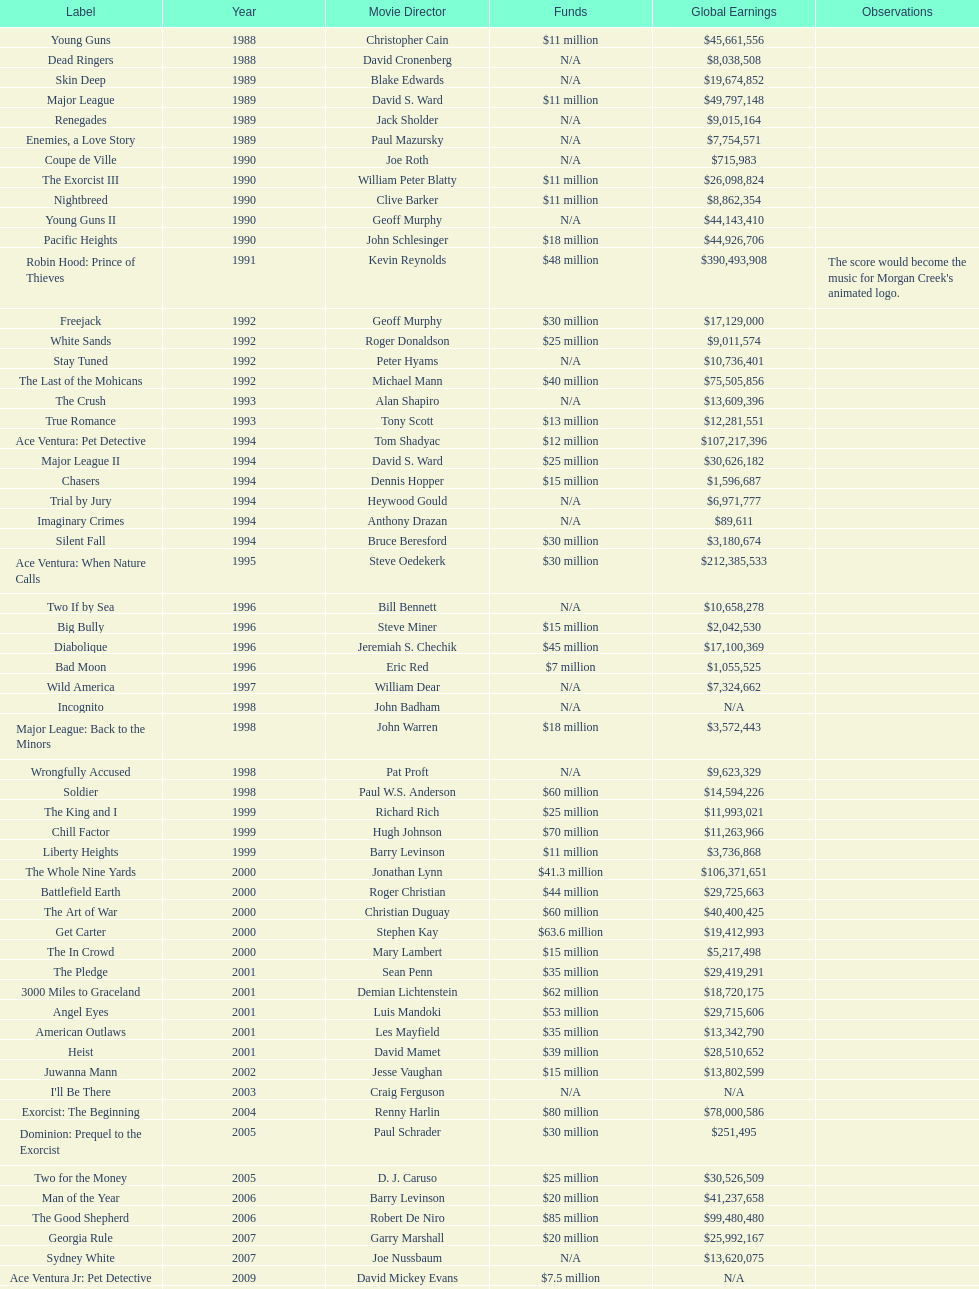Write the full table. {'header': ['Label', 'Year', 'Movie Director', 'Funds', 'Global Earnings', 'Observations'], 'rows': [['Young Guns', '1988', 'Christopher Cain', '$11 million', '$45,661,556', ''], ['Dead Ringers', '1988', 'David Cronenberg', 'N/A', '$8,038,508', ''], ['Skin Deep', '1989', 'Blake Edwards', 'N/A', '$19,674,852', ''], ['Major League', '1989', 'David S. Ward', '$11 million', '$49,797,148', ''], ['Renegades', '1989', 'Jack Sholder', 'N/A', '$9,015,164', ''], ['Enemies, a Love Story', '1989', 'Paul Mazursky', 'N/A', '$7,754,571', ''], ['Coupe de Ville', '1990', 'Joe Roth', 'N/A', '$715,983', ''], ['The Exorcist III', '1990', 'William Peter Blatty', '$11 million', '$26,098,824', ''], ['Nightbreed', '1990', 'Clive Barker', '$11 million', '$8,862,354', ''], ['Young Guns II', '1990', 'Geoff Murphy', 'N/A', '$44,143,410', ''], ['Pacific Heights', '1990', 'John Schlesinger', '$18 million', '$44,926,706', ''], ['Robin Hood: Prince of Thieves', '1991', 'Kevin Reynolds', '$48 million', '$390,493,908', "The score would become the music for Morgan Creek's animated logo."], ['Freejack', '1992', 'Geoff Murphy', '$30 million', '$17,129,000', ''], ['White Sands', '1992', 'Roger Donaldson', '$25 million', '$9,011,574', ''], ['Stay Tuned', '1992', 'Peter Hyams', 'N/A', '$10,736,401', ''], ['The Last of the Mohicans', '1992', 'Michael Mann', '$40 million', '$75,505,856', ''], ['The Crush', '1993', 'Alan Shapiro', 'N/A', '$13,609,396', ''], ['True Romance', '1993', 'Tony Scott', '$13 million', '$12,281,551', ''], ['Ace Ventura: Pet Detective', '1994', 'Tom Shadyac', '$12 million', '$107,217,396', ''], ['Major League II', '1994', 'David S. Ward', '$25 million', '$30,626,182', ''], ['Chasers', '1994', 'Dennis Hopper', '$15 million', '$1,596,687', ''], ['Trial by Jury', '1994', 'Heywood Gould', 'N/A', '$6,971,777', ''], ['Imaginary Crimes', '1994', 'Anthony Drazan', 'N/A', '$89,611', ''], ['Silent Fall', '1994', 'Bruce Beresford', '$30 million', '$3,180,674', ''], ['Ace Ventura: When Nature Calls', '1995', 'Steve Oedekerk', '$30 million', '$212,385,533', ''], ['Two If by Sea', '1996', 'Bill Bennett', 'N/A', '$10,658,278', ''], ['Big Bully', '1996', 'Steve Miner', '$15 million', '$2,042,530', ''], ['Diabolique', '1996', 'Jeremiah S. Chechik', '$45 million', '$17,100,369', ''], ['Bad Moon', '1996', 'Eric Red', '$7 million', '$1,055,525', ''], ['Wild America', '1997', 'William Dear', 'N/A', '$7,324,662', ''], ['Incognito', '1998', 'John Badham', 'N/A', 'N/A', ''], ['Major League: Back to the Minors', '1998', 'John Warren', '$18 million', '$3,572,443', ''], ['Wrongfully Accused', '1998', 'Pat Proft', 'N/A', '$9,623,329', ''], ['Soldier', '1998', 'Paul W.S. Anderson', '$60 million', '$14,594,226', ''], ['The King and I', '1999', 'Richard Rich', '$25 million', '$11,993,021', ''], ['Chill Factor', '1999', 'Hugh Johnson', '$70 million', '$11,263,966', ''], ['Liberty Heights', '1999', 'Barry Levinson', '$11 million', '$3,736,868', ''], ['The Whole Nine Yards', '2000', 'Jonathan Lynn', '$41.3 million', '$106,371,651', ''], ['Battlefield Earth', '2000', 'Roger Christian', '$44 million', '$29,725,663', ''], ['The Art of War', '2000', 'Christian Duguay', '$60 million', '$40,400,425', ''], ['Get Carter', '2000', 'Stephen Kay', '$63.6 million', '$19,412,993', ''], ['The In Crowd', '2000', 'Mary Lambert', '$15 million', '$5,217,498', ''], ['The Pledge', '2001', 'Sean Penn', '$35 million', '$29,419,291', ''], ['3000 Miles to Graceland', '2001', 'Demian Lichtenstein', '$62 million', '$18,720,175', ''], ['Angel Eyes', '2001', 'Luis Mandoki', '$53 million', '$29,715,606', ''], ['American Outlaws', '2001', 'Les Mayfield', '$35 million', '$13,342,790', ''], ['Heist', '2001', 'David Mamet', '$39 million', '$28,510,652', ''], ['Juwanna Mann', '2002', 'Jesse Vaughan', '$15 million', '$13,802,599', ''], ["I'll Be There", '2003', 'Craig Ferguson', 'N/A', 'N/A', ''], ['Exorcist: The Beginning', '2004', 'Renny Harlin', '$80 million', '$78,000,586', ''], ['Dominion: Prequel to the Exorcist', '2005', 'Paul Schrader', '$30 million', '$251,495', ''], ['Two for the Money', '2005', 'D. J. Caruso', '$25 million', '$30,526,509', ''], ['Man of the Year', '2006', 'Barry Levinson', '$20 million', '$41,237,658', ''], ['The Good Shepherd', '2006', 'Robert De Niro', '$85 million', '$99,480,480', ''], ['Georgia Rule', '2007', 'Garry Marshall', '$20 million', '$25,992,167', ''], ['Sydney White', '2007', 'Joe Nussbaum', 'N/A', '$13,620,075', ''], ['Ace Ventura Jr: Pet Detective', '2009', 'David Mickey Evans', '$7.5 million', 'N/A', ''], ['Dream House', '2011', 'Jim Sheridan', '$50 million', '$38,502,340', ''], ['The Thing', '2011', 'Matthijs van Heijningen Jr.', '$38 million', '$27,428,670', ''], ['Tupac', '2014', 'Antoine Fuqua', '$45 million', '', '']]} After young guns, what was the next movie with the exact same budget? Major League. 